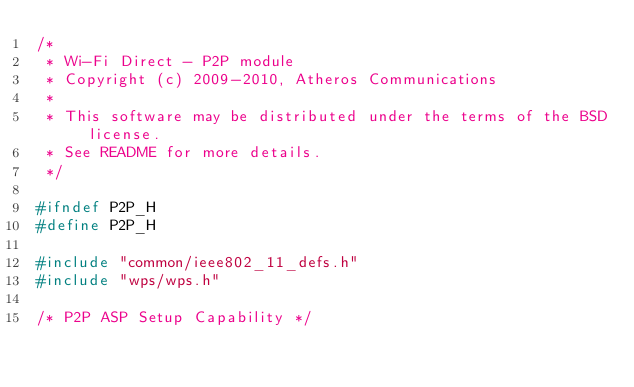<code> <loc_0><loc_0><loc_500><loc_500><_C_>/*
 * Wi-Fi Direct - P2P module
 * Copyright (c) 2009-2010, Atheros Communications
 *
 * This software may be distributed under the terms of the BSD license.
 * See README for more details.
 */

#ifndef P2P_H
#define P2P_H

#include "common/ieee802_11_defs.h"
#include "wps/wps.h"

/* P2P ASP Setup Capability */</code> 